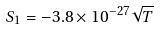Convert formula to latex. <formula><loc_0><loc_0><loc_500><loc_500>S _ { 1 } = - 3 . 8 \times 1 0 ^ { - 2 7 } \sqrt { T }</formula> 